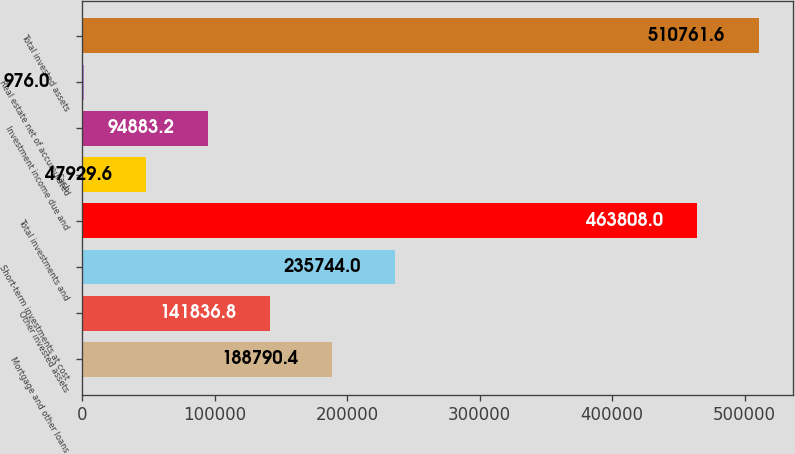<chart> <loc_0><loc_0><loc_500><loc_500><bar_chart><fcel>Mortgage and other loans<fcel>Other invested assets<fcel>Short-term investments at cost<fcel>Total investments and<fcel>Cash<fcel>Investment income due and<fcel>Real estate net of accumulated<fcel>Total invested assets<nl><fcel>188790<fcel>141837<fcel>235744<fcel>463808<fcel>47929.6<fcel>94883.2<fcel>976<fcel>510762<nl></chart> 